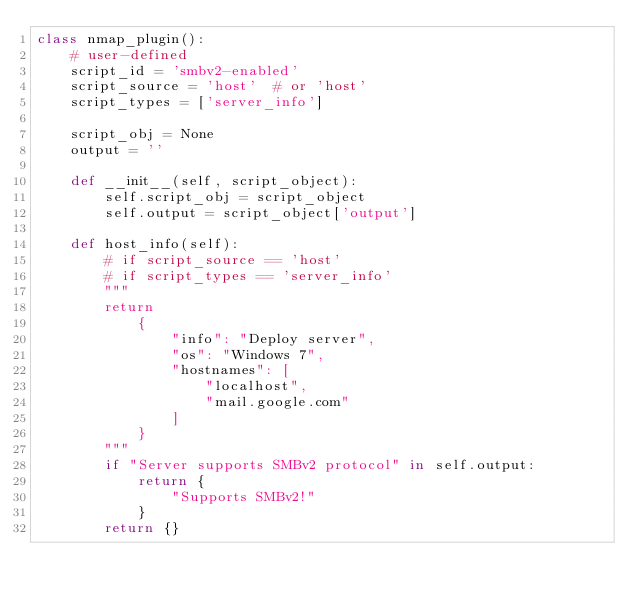Convert code to text. <code><loc_0><loc_0><loc_500><loc_500><_Python_>class nmap_plugin():
    # user-defined
    script_id = 'smbv2-enabled'
    script_source = 'host'  # or 'host'
    script_types = ['server_info']

    script_obj = None
    output = ''

    def __init__(self, script_object):
        self.script_obj = script_object
        self.output = script_object['output']

    def host_info(self):
        # if script_source == 'host'
        # if script_types == 'server_info'
        """
        return
            {
                "info": "Deploy server",
                "os": "Windows 7",
                "hostnames": [
                    "localhost",
                    "mail.google.com"
                ]
            }
        """
        if "Server supports SMBv2 protocol" in self.output:
            return {
                "Supports SMBv2!"
            }
        return {}
</code> 